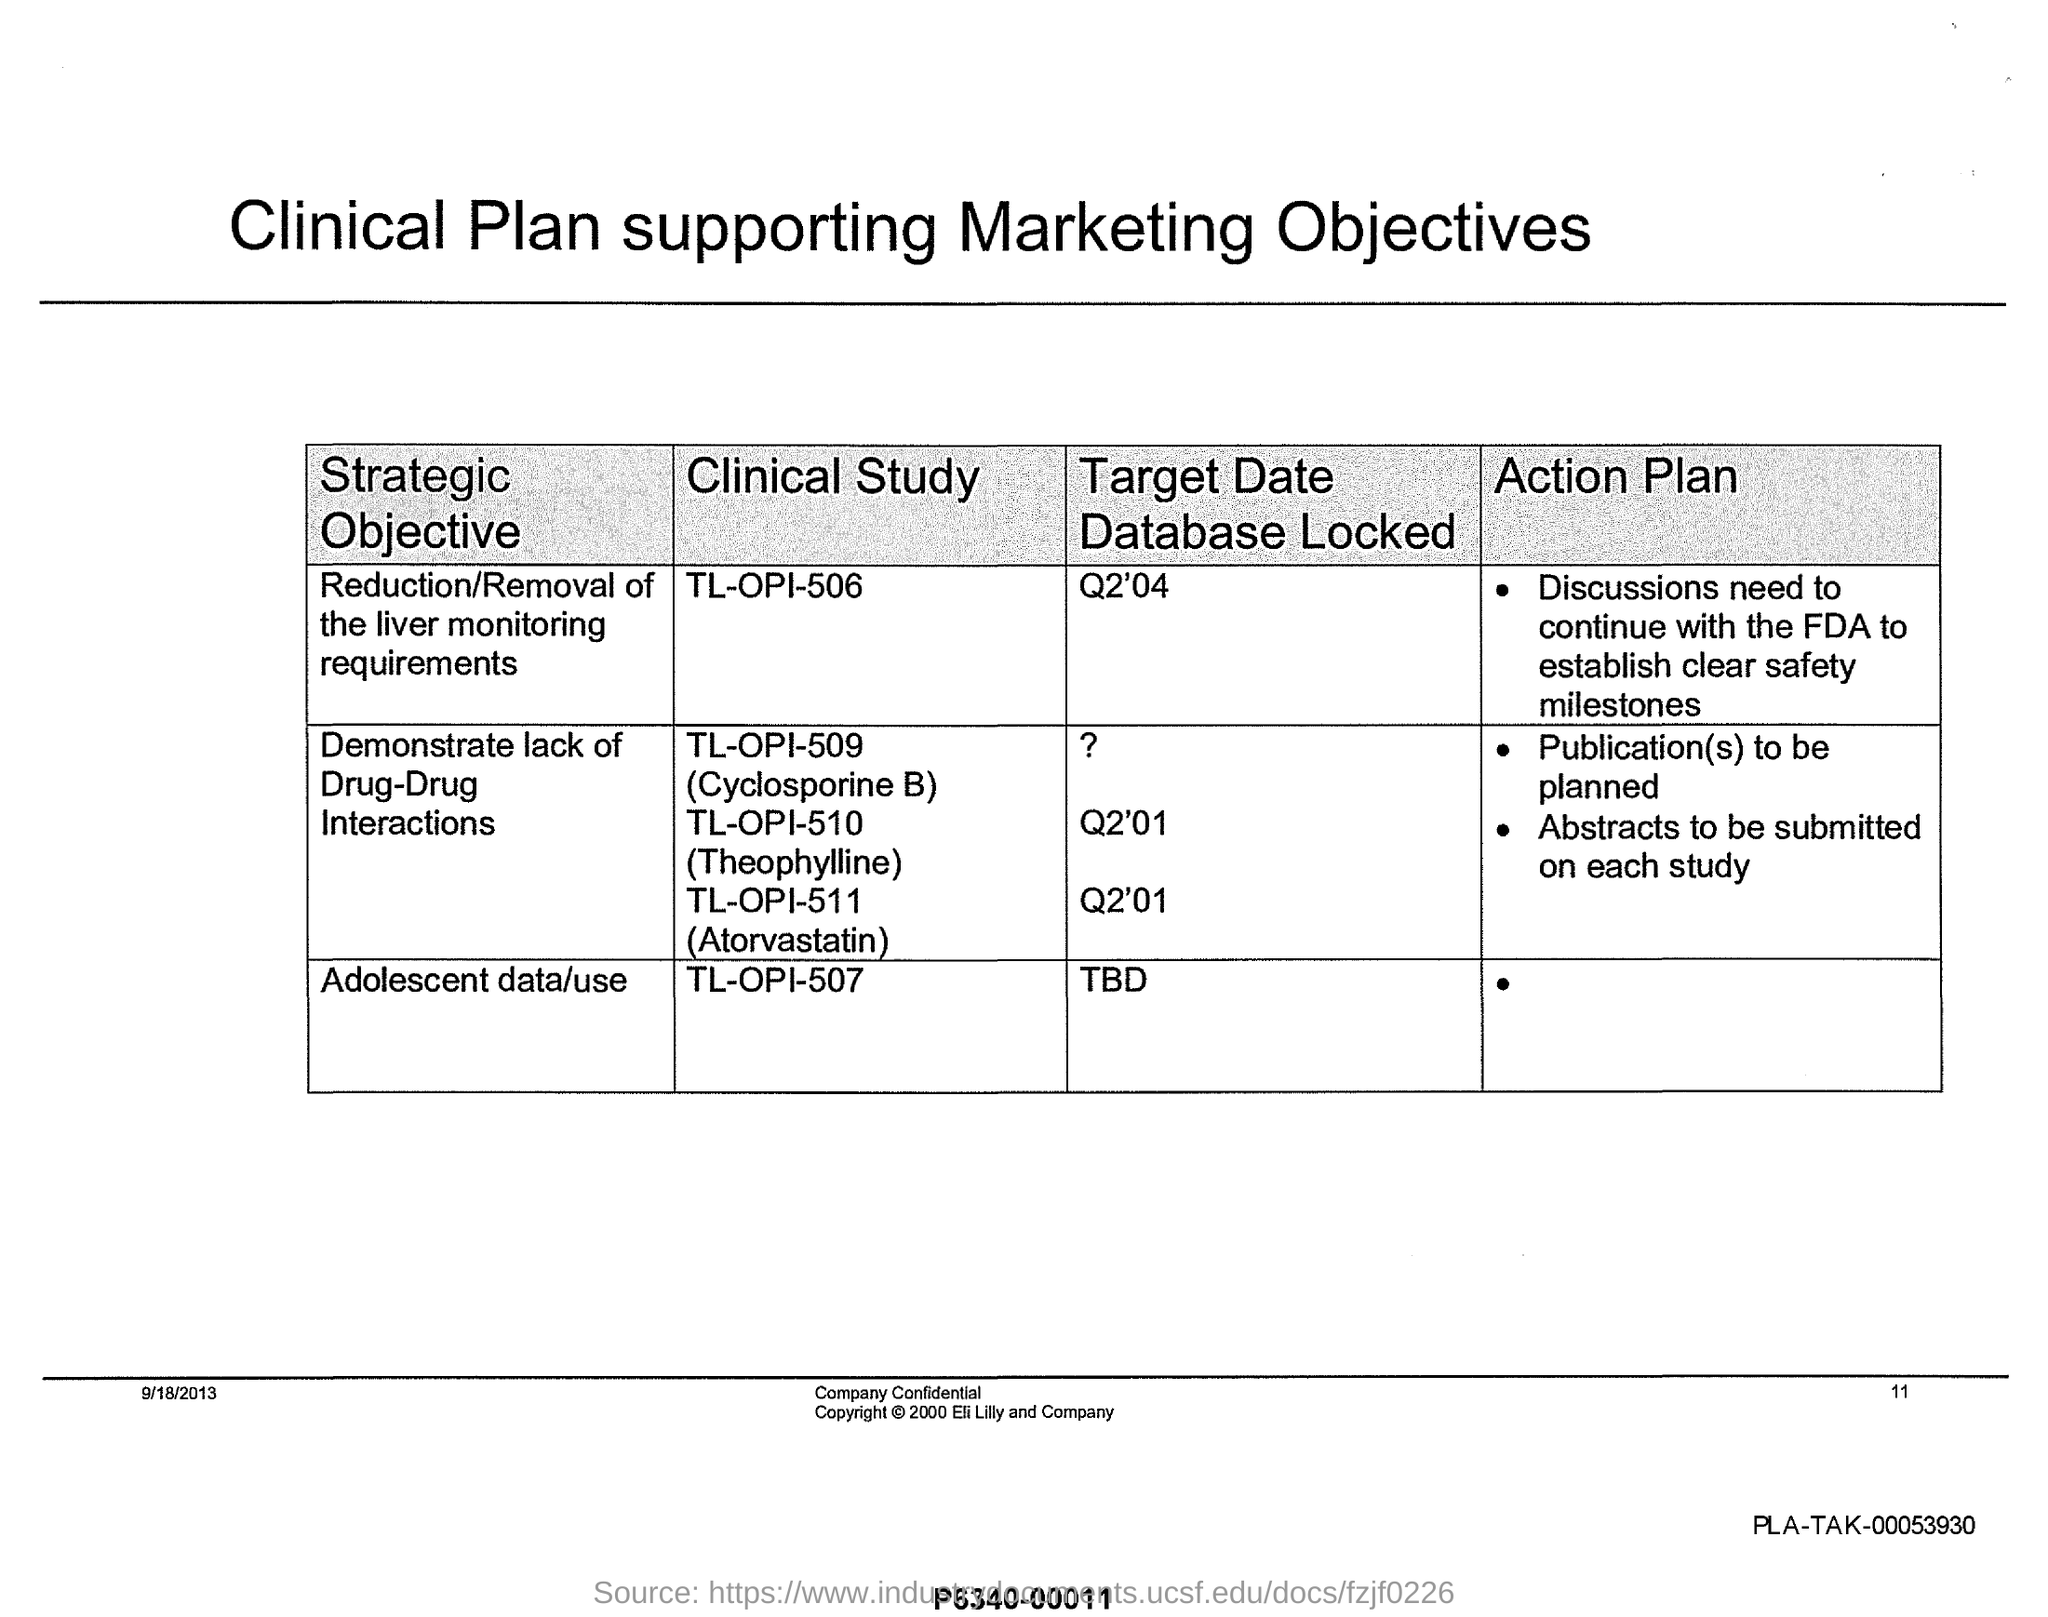What is the heading of the table given at the top of the page?
Offer a very short reply. Clinical Plan supporting Marketing Objectives. What is the heading of the first column of the table?
Your answer should be very brief. Strategic Objective. What is the heading of the second column of the table?
Offer a very short reply. Clinical Study. What is the heading of the third column of the table?
Make the answer very short. Target Date Database Locked. What is the heading of the fourth column of the table?
Your response must be concise. Action Plan. What is the "Clinical Study" for "Adolescent data/use"?
Make the answer very short. TL-OPI-507. What is the "Target Date Database Locked" for "Adolescent data/use"?
Provide a short and direct response. TBD. What is the "Target Date Database Locked" for "Reduction/Removal of the liver monitoring requirements"?
Give a very brief answer. Q2'04. What is the "Clinical Study" for "Reduction/Removal of the liver monitoring requirements"?
Your response must be concise. TL-OPI-506. What is the DATE mentioned at the left bottom of the page?
Give a very brief answer. 9/18/2013. What is the "PLA-TAK" number mentioned at the right bottom of the page?
Give a very brief answer. PLA-TAK-00053930. 